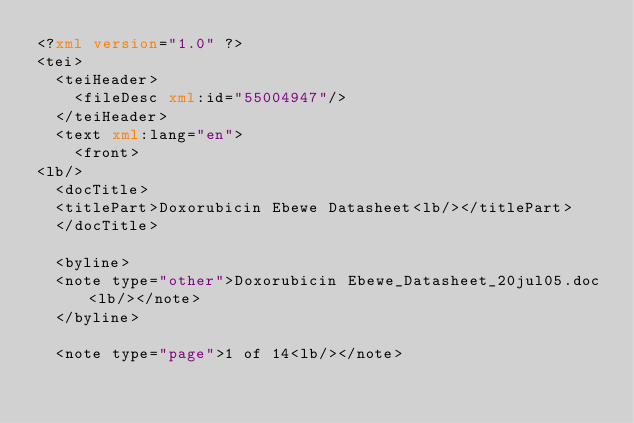<code> <loc_0><loc_0><loc_500><loc_500><_XML_><?xml version="1.0" ?>
<tei>
	<teiHeader>
		<fileDesc xml:id="55004947"/>
	</teiHeader>
	<text xml:lang="en">
		<front>
<lb/>
	<docTitle>
	<titlePart>Doxorubicin Ebewe Datasheet<lb/></titlePart>
	</docTitle>

	<byline>
	<note type="other">Doxorubicin Ebewe_Datasheet_20jul05.doc<lb/></note>
	</byline>

	<note type="page">1 of 14<lb/></note>
</code> 